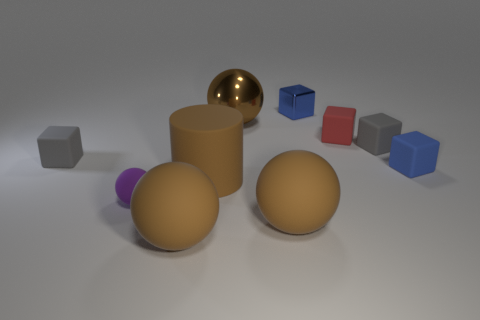Are there any large brown things in front of the purple matte ball?
Your response must be concise. Yes. Do the large brown metal object and the small gray thing to the left of the big brown rubber cylinder have the same shape?
Provide a short and direct response. No. How many objects are either blocks right of the metallic sphere or tiny metal cubes?
Keep it short and to the point. 4. How many tiny matte objects are both to the left of the small red rubber cube and behind the small purple rubber thing?
Ensure brevity in your answer.  1. What number of things are either tiny gray matte cubes that are right of the brown metal sphere or small blue cubes in front of the big brown metal ball?
Your answer should be very brief. 2. What number of other objects are there of the same shape as the large brown metal object?
Provide a succinct answer. 3. There is a big matte thing that is right of the big brown cylinder; is its color the same as the big matte cylinder?
Provide a succinct answer. Yes. How many other objects are the same size as the purple sphere?
Make the answer very short. 5. Do the small red object and the brown cylinder have the same material?
Provide a short and direct response. Yes. The rubber sphere on the right side of the big brown ball to the left of the brown cylinder is what color?
Offer a terse response. Brown. 